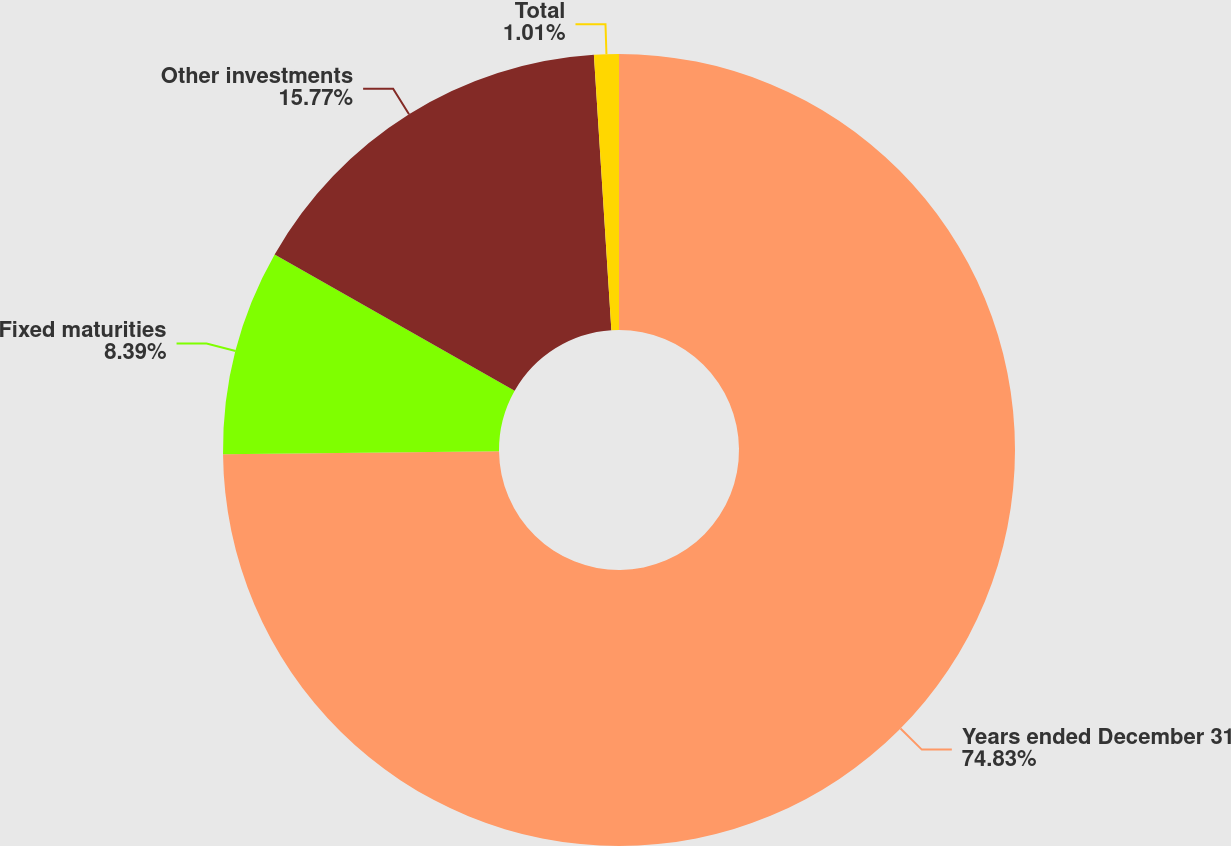Convert chart to OTSL. <chart><loc_0><loc_0><loc_500><loc_500><pie_chart><fcel>Years ended December 31<fcel>Fixed maturities<fcel>Other investments<fcel>Total<nl><fcel>74.83%<fcel>8.39%<fcel>15.77%<fcel>1.01%<nl></chart> 